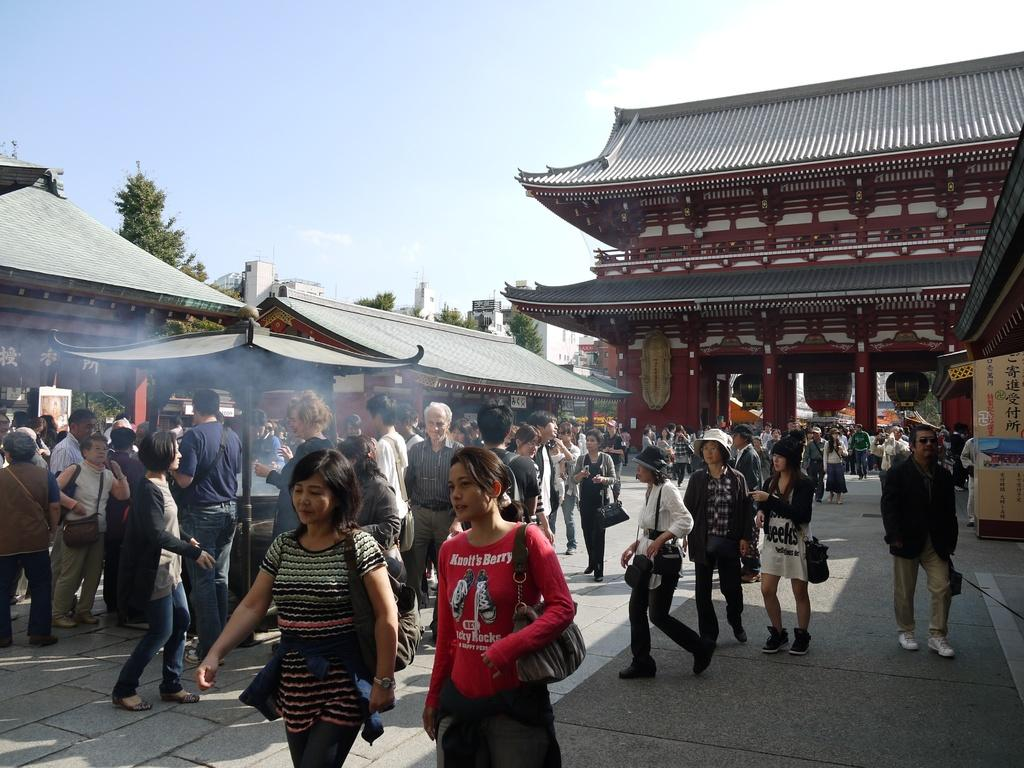What is the main subject of the image? The main subject of the image is a group of people on the ground. What type of structures can be seen in the image? There are buildings with roofs in the image. What other objects are present in the image? There are poles, boards, and trees in the image. What can be seen in the background of the image? The sky is visible in the image. What type of locket is being worn by the beginner in the image? There is no mention of a locket or a beginner in the image, so it is not possible to answer that question. 